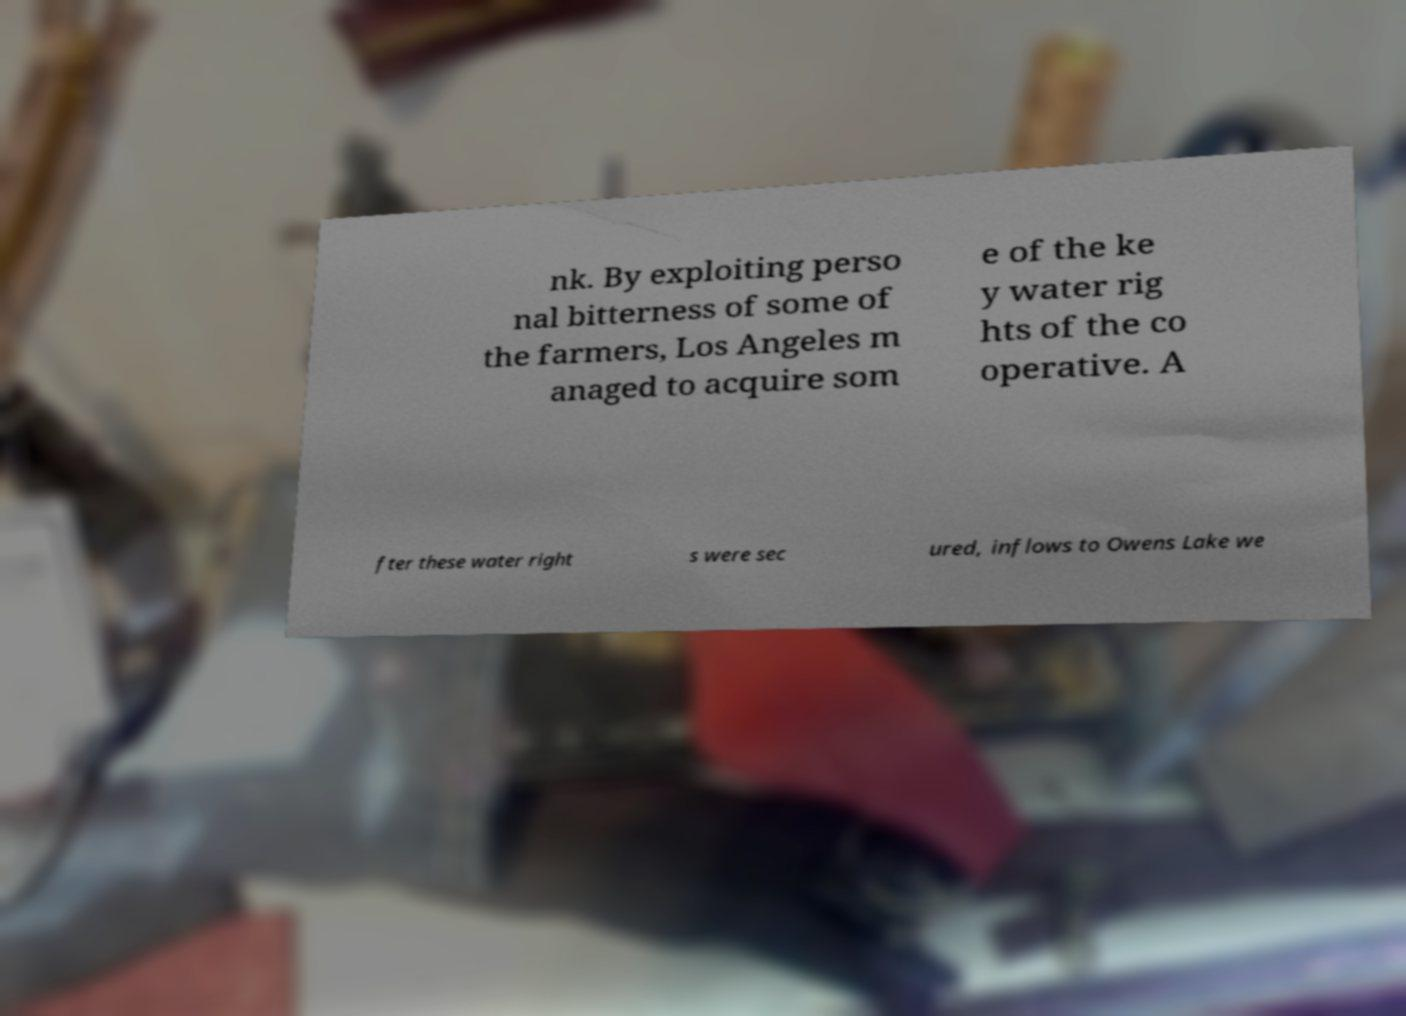Please read and relay the text visible in this image. What does it say? nk. By exploiting perso nal bitterness of some of the farmers, Los Angeles m anaged to acquire som e of the ke y water rig hts of the co operative. A fter these water right s were sec ured, inflows to Owens Lake we 